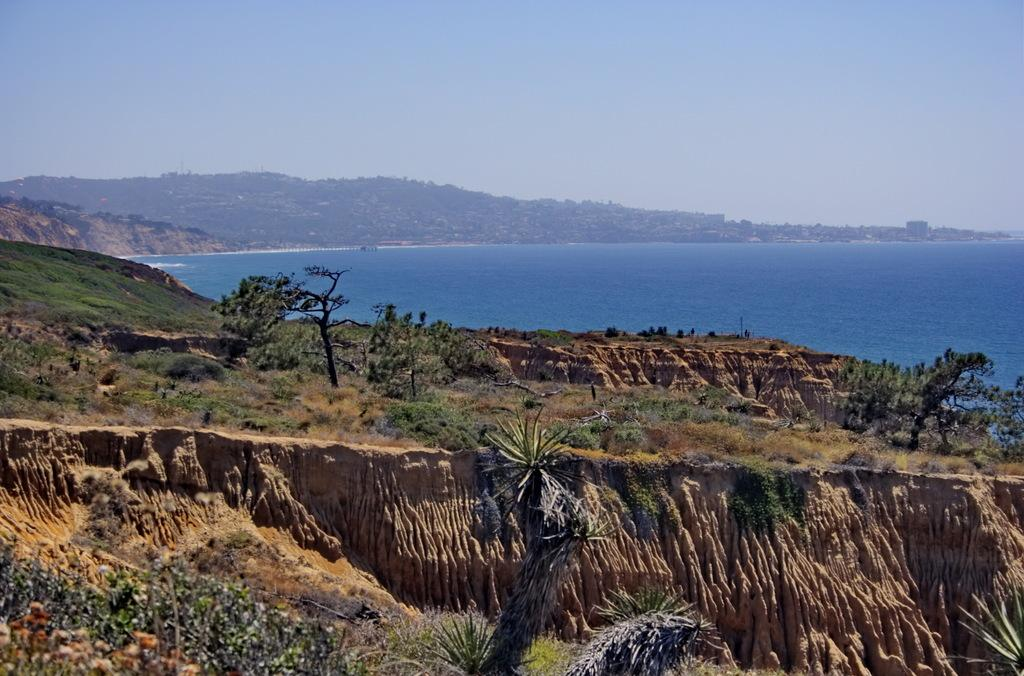What type of vegetation is present in the image? There are many trees in the image. What type of ground cover can be seen in the image? There is grass visible in the image. What can be seen in the distance in the image? There is water and mountains in the background of the image. What is visible above the mountains in the image? The sky is visible in the background of the image. What type of sheet is draped over the trees in the image? There is no sheet present in the image; it features trees, grass, water, mountains, and the sky. 